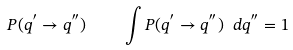<formula> <loc_0><loc_0><loc_500><loc_500>P ( q ^ { ^ { \prime } } \to q ^ { ^ { \prime \prime } } ) \quad \int P ( q ^ { ^ { \prime } } \to q ^ { ^ { \prime \prime } } ) \ d q ^ { ^ { \prime \prime } } = 1</formula> 